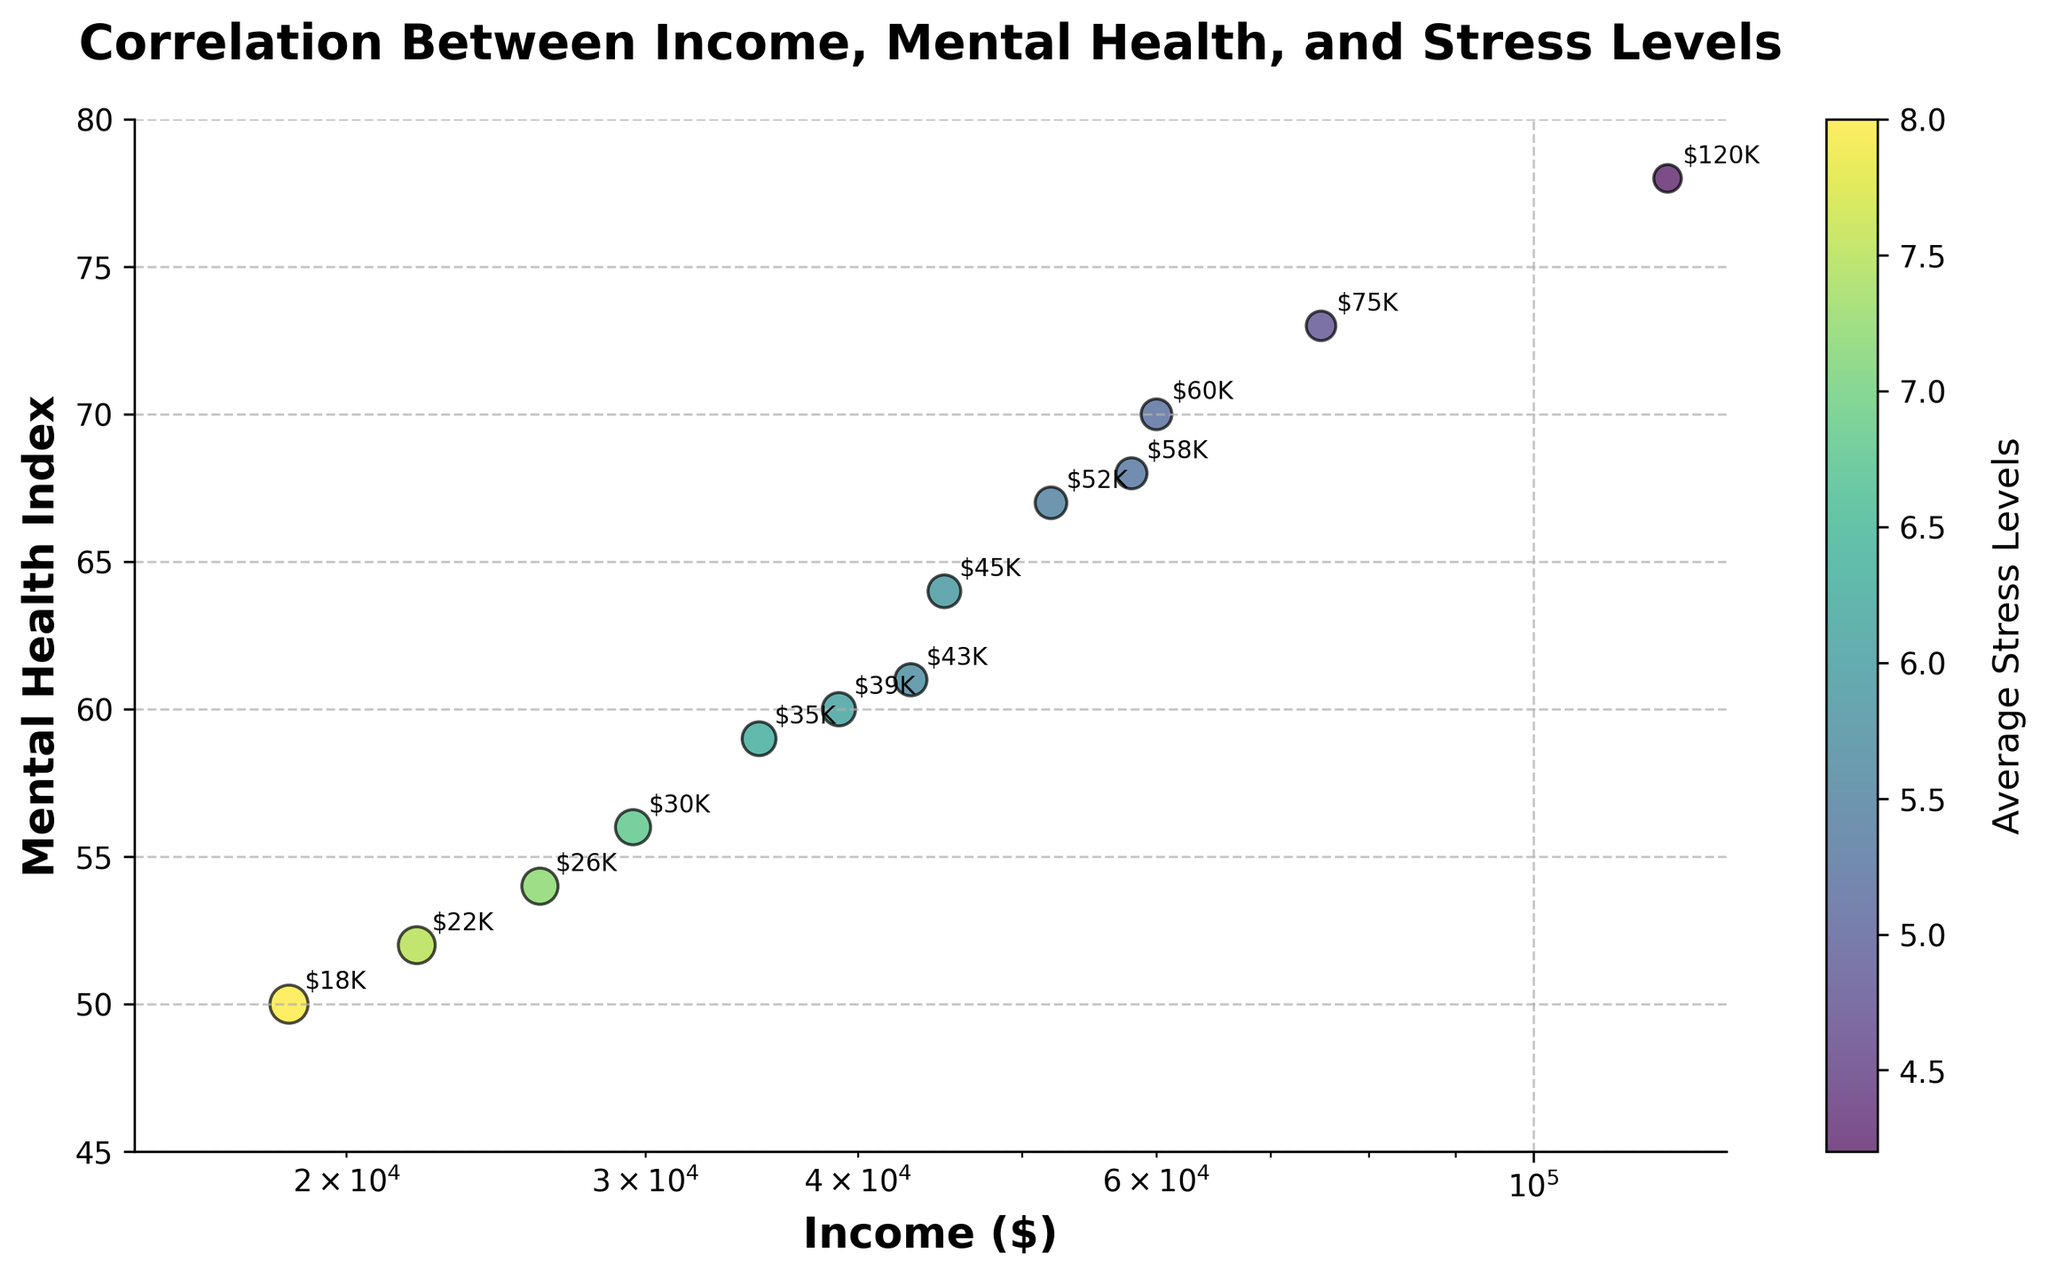How many data points are shown in the scatter plot? The figure shows the correlation between Income and Mental Health Index with stress levels as another variable. By simply counting the number of data points visible, we see there are 13 points in the plot.
Answer: 13 What is the title of the scatter plot? The title is clearly displayed at the top of the plot to describe the visualized relationship. In this case, the title is "Correlation Between Income, Mental Health, and Stress Levels."
Answer: Correlation Between Income, Mental Health, and Stress Levels What is the income level associated with the highest Mental Health Index? To find this, identify the data point corresponding to the highest Mental Health Index on the y-axis. This data point has an Income of $120,000 and a Mental Health Index of 78.
Answer: $120,000 Which data point has the highest average stress level? By looking at the color bar and identifying the darkest point (assuming darker means higher stress), we see the highest stress level of 8.0 is associated with an income of $18,500.
Answer: $18,500 How does the Mental Health Index change with increasing income levels? By examining the scatter plot, it's observable that as income increases, there is a general upward trend in the Mental Health Index, meaning higher income is associated with a better Mental Health Index.
Answer: Better Mental Health Index with higher income What is the relationship between stress levels and income for lower-income individuals (below $30,000)? Focusing on data points below the $30,000 income threshold, we observe that these points generally have higher average stress levels (all above 7.0).
Answer: Higher stress levels Does the plot show a positive correlation between income and Mental Health Index? From the scatter plot, a majority of the points show a rising trend along the y-axis (Mental Health Index) as the x-axis (income) increases. This signifies a positive correlation.
Answer: Yes Which data point shows a relatively high Mental Health Index but also higher stress levels compared to its nearby points? By examining the points carefully and comparing them, the data point with an income of $45,000 has a relatively high Mental Health Index (64) but also a higher stress level (5.9) than most points in its vicinity.
Answer: $45,000 Calculate the difference in Mental Health Index between the lowest income ($18,500) and the highest income ($120,000). Subtract the Mental Health Index of the lowest income (50) from the highest income (78): 78 - 50 = 28.
Answer: 28 Which income group has the smallest data point size (suggesting lower stress levels)? By inspecting the sizes of the data points, the smallest point size corresponds to $120,000 income, indicating the lowest stress level of 4.2.
Answer: $120,000 